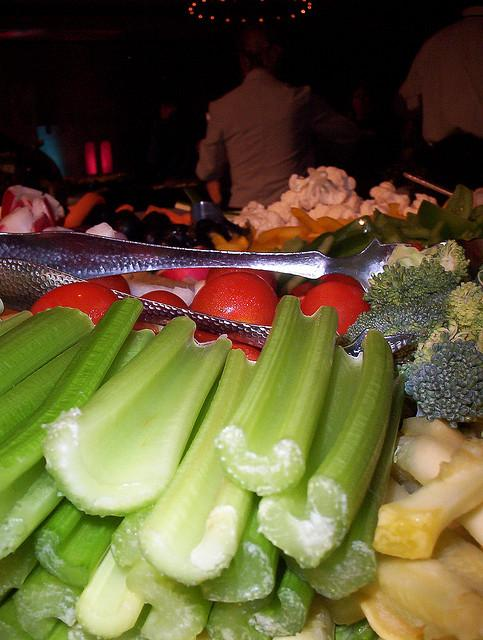What type of silver utensil sits atop the salad bar? Please explain your reasoning. tongs. Silver tongs are open on top of the tomatoes. 